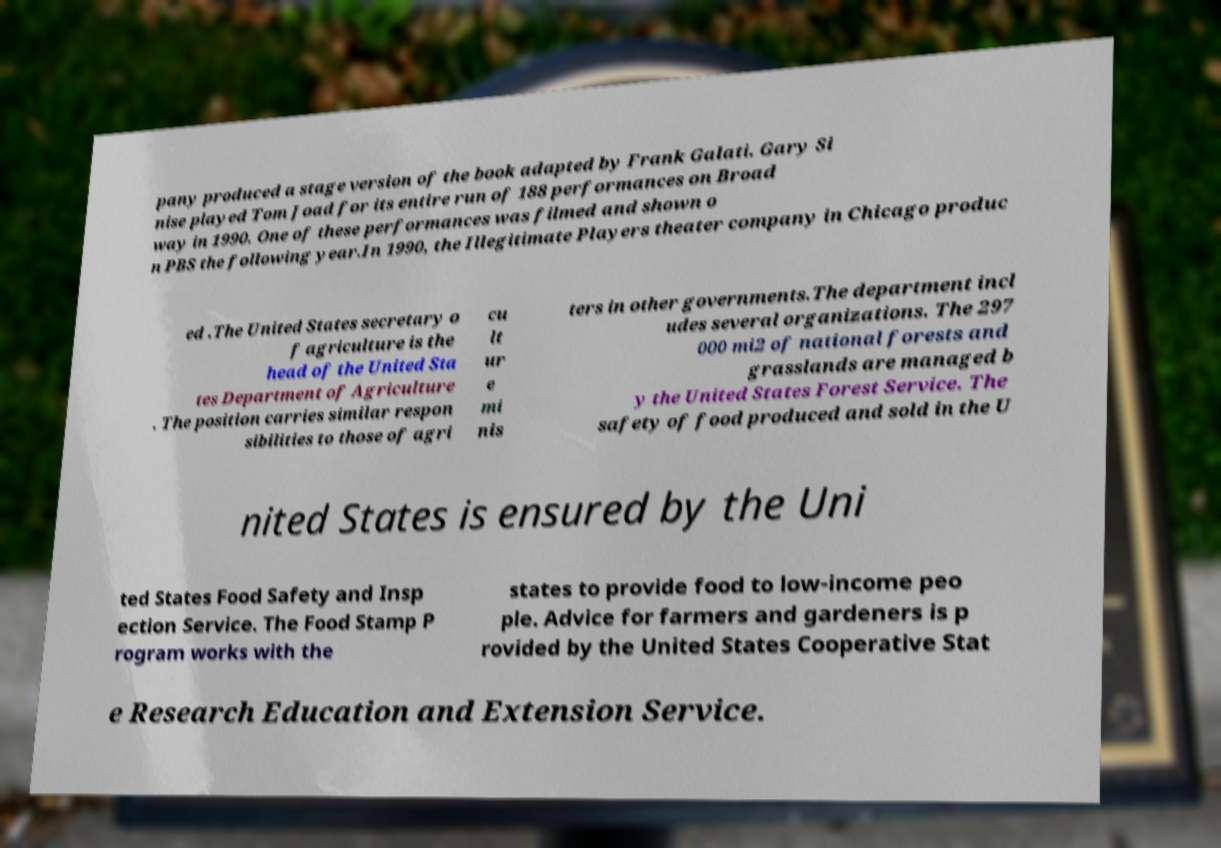Could you extract and type out the text from this image? pany produced a stage version of the book adapted by Frank Galati. Gary Si nise played Tom Joad for its entire run of 188 performances on Broad way in 1990. One of these performances was filmed and shown o n PBS the following year.In 1990, the Illegitimate Players theater company in Chicago produc ed .The United States secretary o f agriculture is the head of the United Sta tes Department of Agriculture . The position carries similar respon sibilities to those of agri cu lt ur e mi nis ters in other governments.The department incl udes several organizations. The 297 000 mi2 of national forests and grasslands are managed b y the United States Forest Service. The safety of food produced and sold in the U nited States is ensured by the Uni ted States Food Safety and Insp ection Service. The Food Stamp P rogram works with the states to provide food to low-income peo ple. Advice for farmers and gardeners is p rovided by the United States Cooperative Stat e Research Education and Extension Service. 